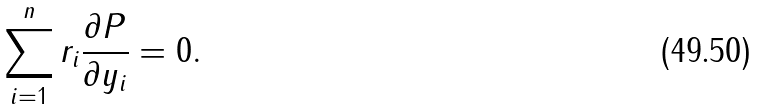Convert formula to latex. <formula><loc_0><loc_0><loc_500><loc_500>\sum ^ { n } _ { i = 1 } r _ { i } \frac { \partial P } { \partial y _ { i } } = 0 .</formula> 